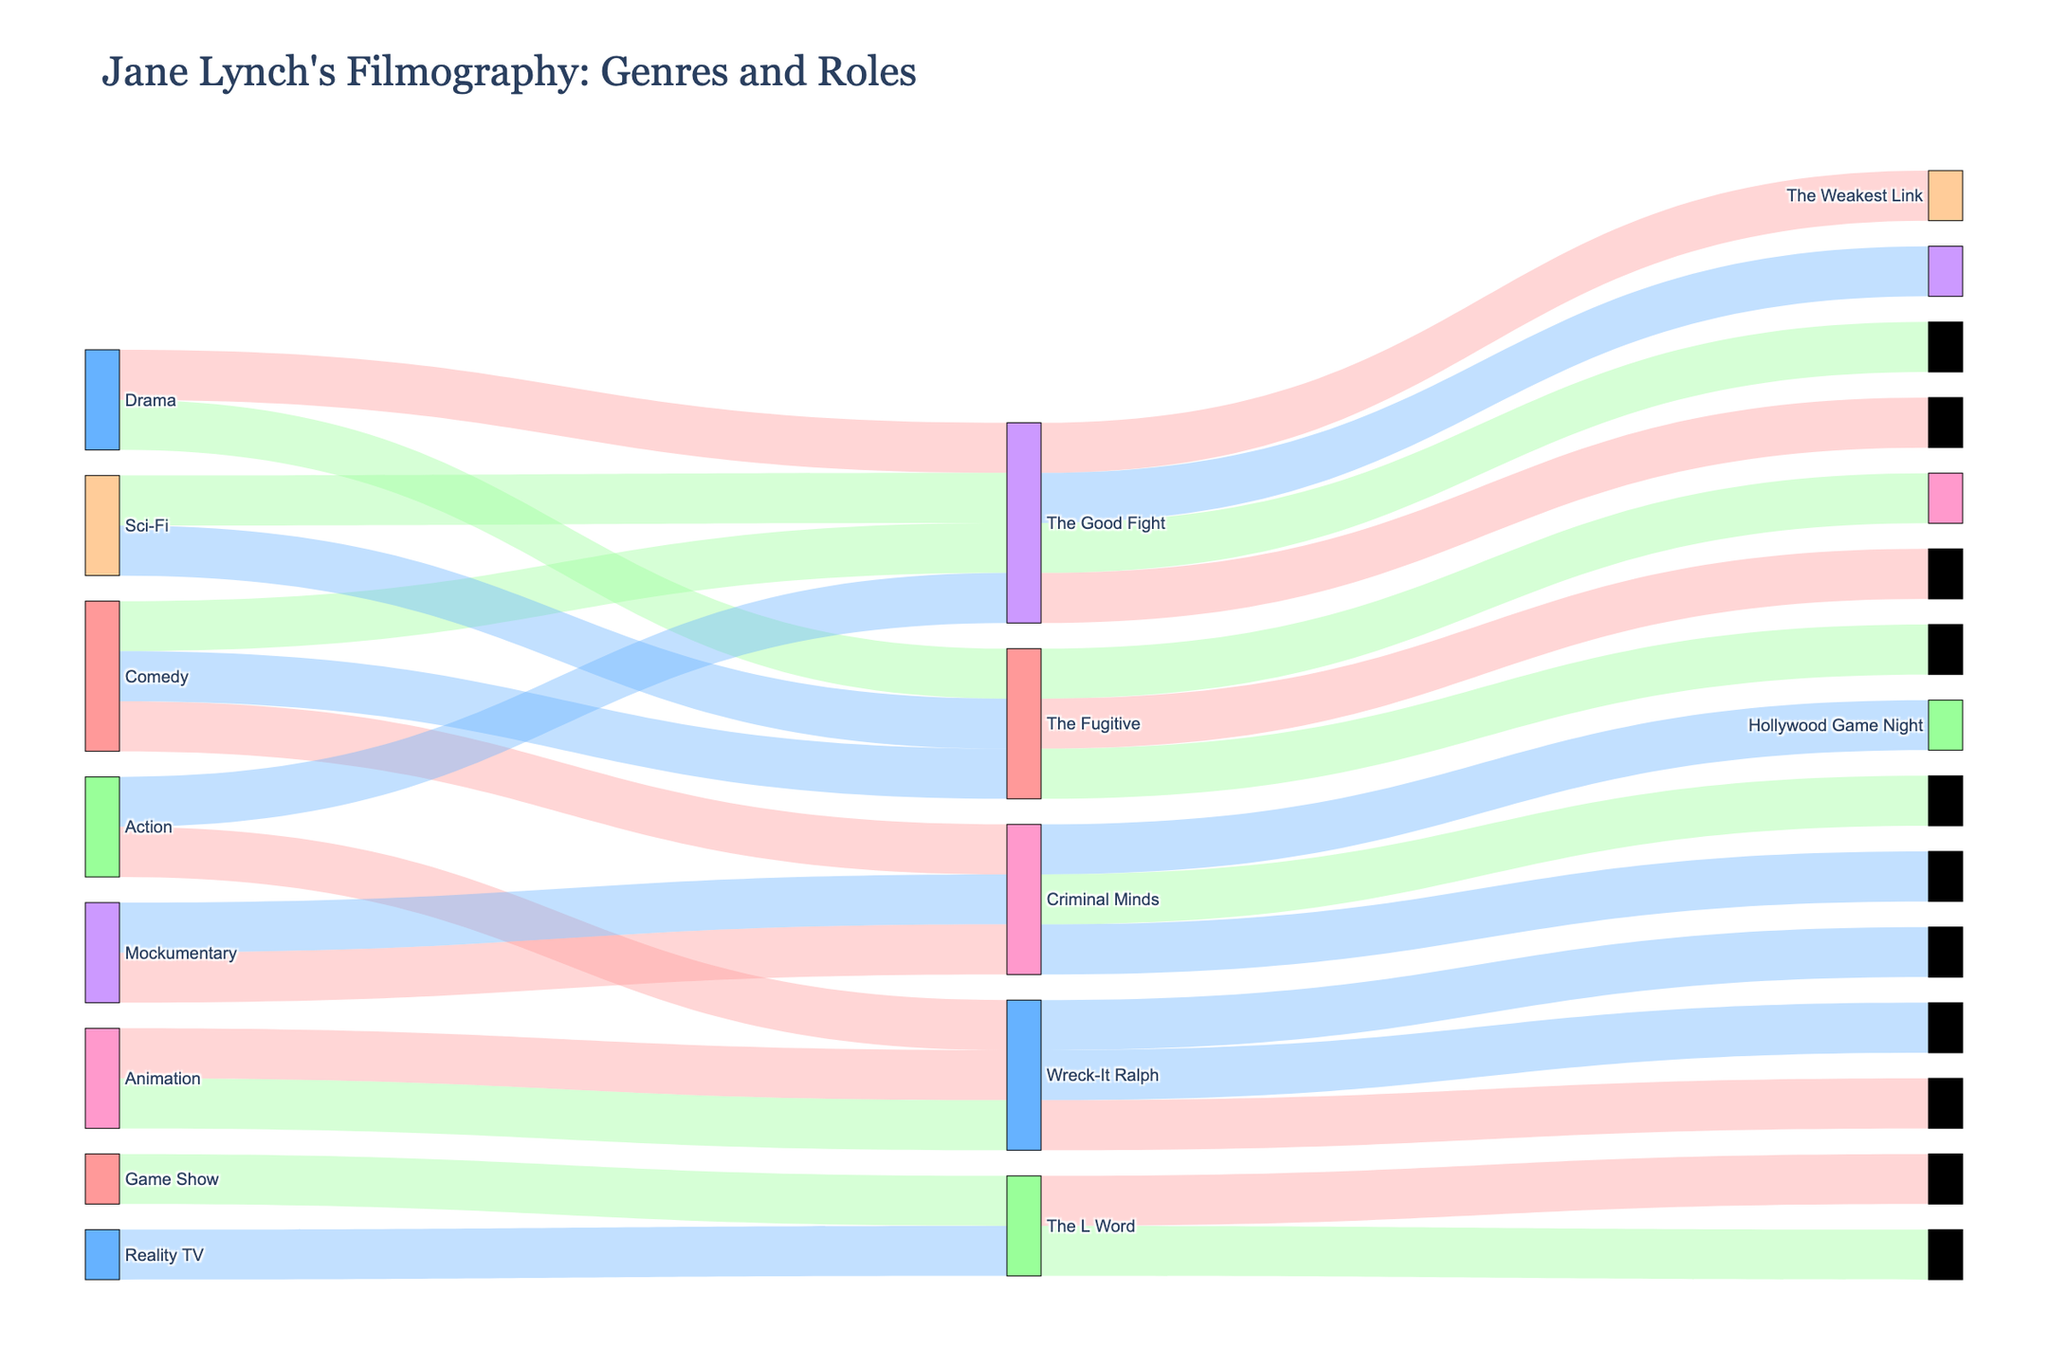How many genres are represented in Jane Lynch's filmography according to the Sankey diagram? Count the distinct genres labeled in the diagram.
Answer: 6 What role type has the most titles associated with it? Identify the role type with the most connections to titles.
Answer: Voice Actor Which genre has the most variety in role types? Look at the genre connected to the most varied role types.
Answer: Comedy How many titles fall under the "Host" role type? Count the number of connections to titles from the "Host" role type.
Answer: 2 How many titles does Jane Lynch have in the Mockumentary genre? Count the number of connections from the "Mockumentary" genre to titles.
Answer: 2 Compare the number of titles in the Animation genre to the Action genre. Which has more? Compare the number of connections from "Animation" to "Action" and count titles.
Answer: Animation In which genre does Jane Lynch play the main cast the most? Identify the genre with connections to "Main Cast" and count them.
Answer: Mockumentary List all the titles where Jane Lynch has a supporting role. Identify all titles connected to the "Supporting" role type.
Answer: The 40-Year-Old Virgin, Criminal Minds, The Fugitive, The L Word How many titles does Jane Lynch have in the Comedy genre as a guest star? Count the connections from "Comedy" to "Guest Star" and titles.
Answer: 1 